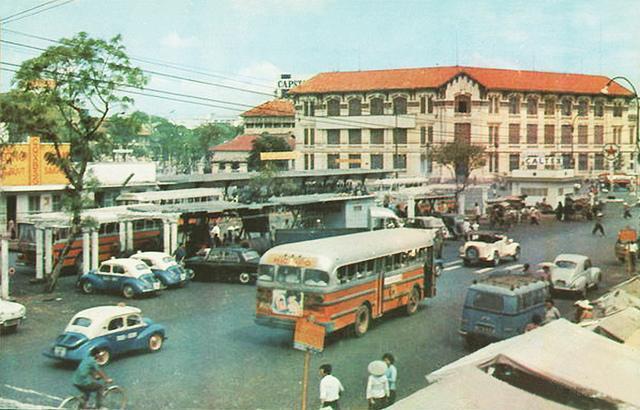What is the name of the gas station with the red star?
From the following set of four choices, select the accurate answer to respond to the question.
Options: Shell, sinclair, texaco, caltex. Caltex. 